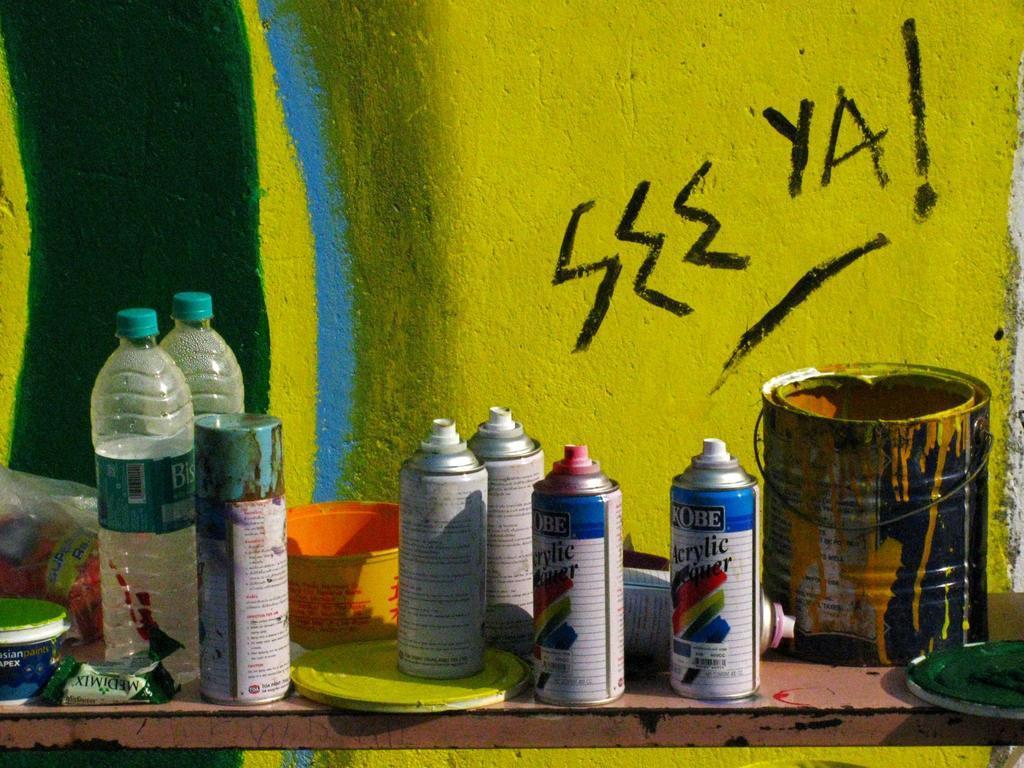In one or two sentences, can you explain what this image depicts? On the table there are six bottle and to the right side there is a paint box, in front of it there is a lid. And in the middle there is a orange color bowl and two water bottles. To the left side there is a box and packet on it. And on the wall there is a green, yellow and blue colors painted on it. 